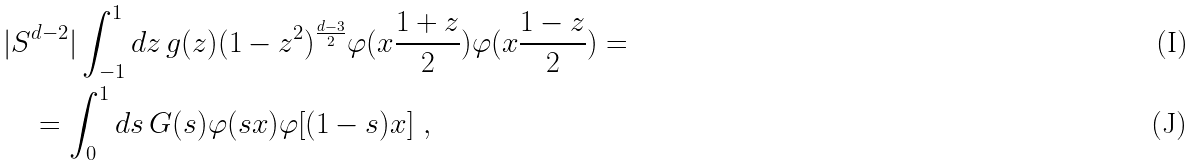Convert formula to latex. <formula><loc_0><loc_0><loc_500><loc_500>& | S ^ { d - 2 } | \int _ { - 1 } ^ { 1 } d z \, g ( z ) ( 1 - z ^ { 2 } ) ^ { \frac { d - 3 } 2 } \varphi ( x \frac { 1 + z } 2 ) \varphi ( x \frac { 1 - z } 2 ) = \\ & \quad = \int _ { 0 } ^ { 1 } d s \, G ( s ) \varphi ( s x ) \varphi [ ( 1 - s ) x ] \ ,</formula> 